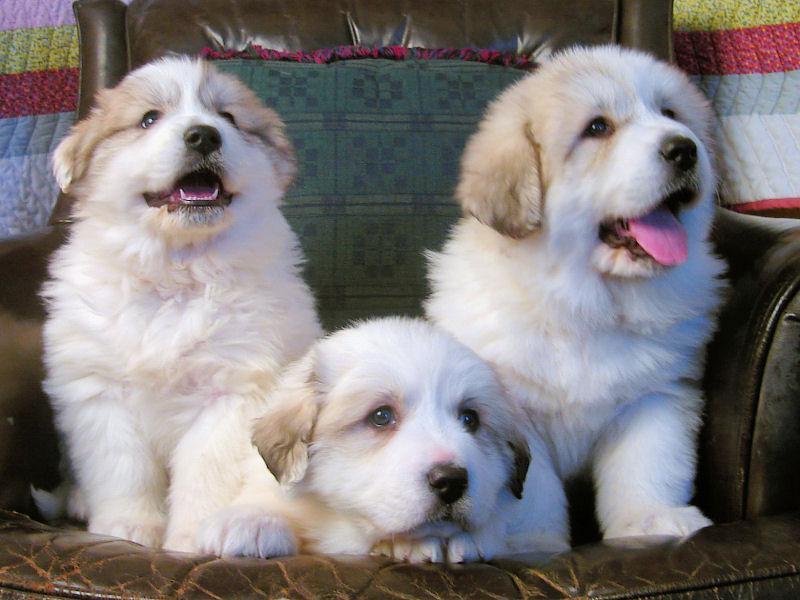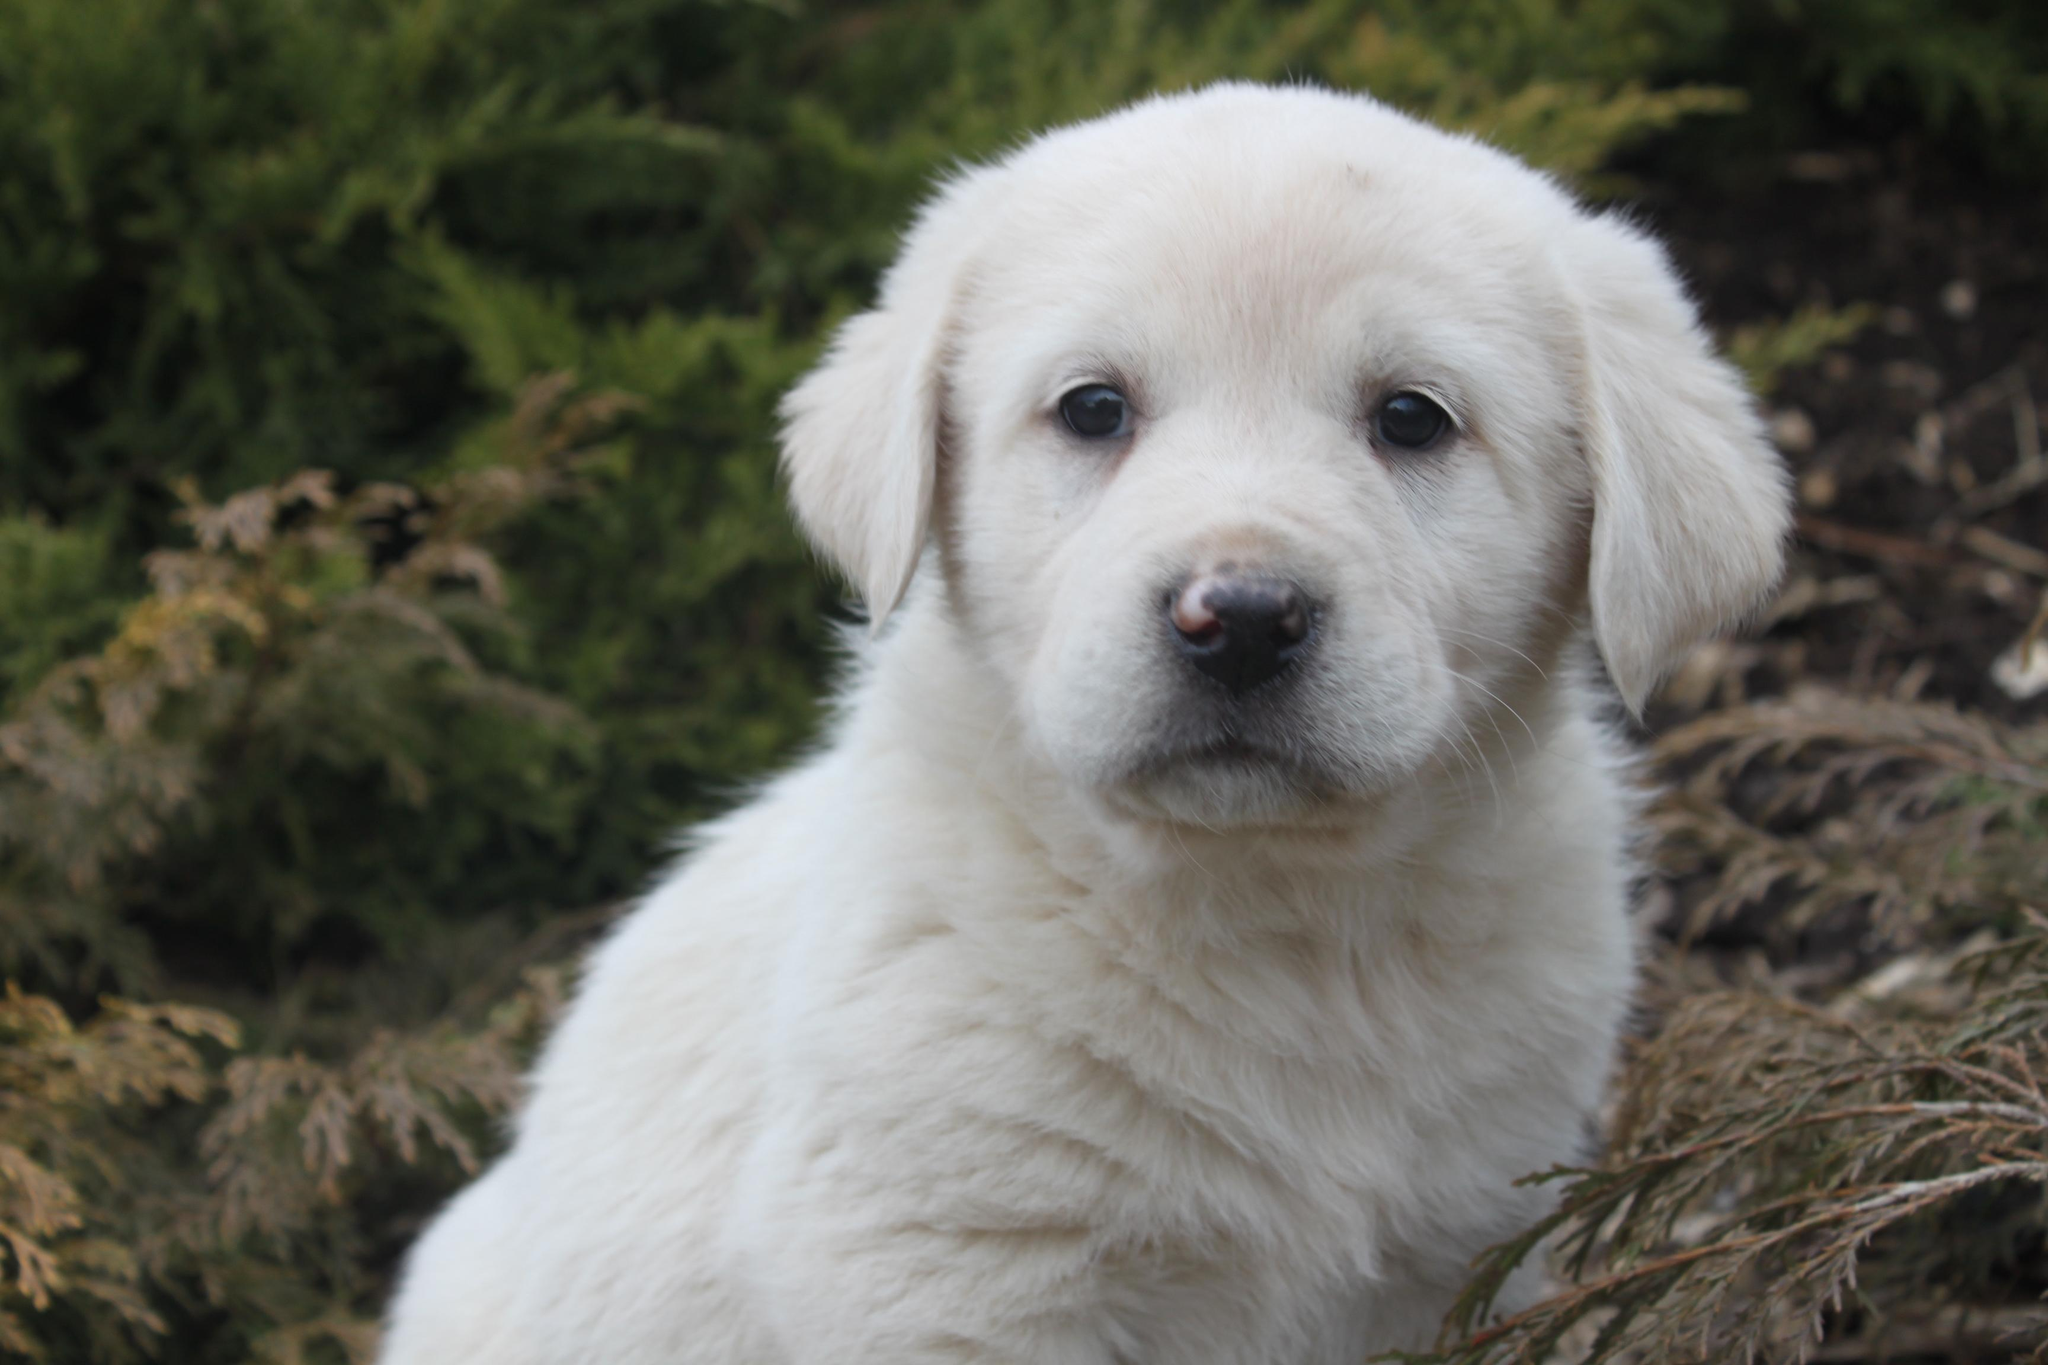The first image is the image on the left, the second image is the image on the right. For the images shown, is this caption "There are two dogs together in front of a visible sky in each image." true? Answer yes or no. No. The first image is the image on the left, the second image is the image on the right. Considering the images on both sides, is "The sky is visible in both of the images." valid? Answer yes or no. No. 